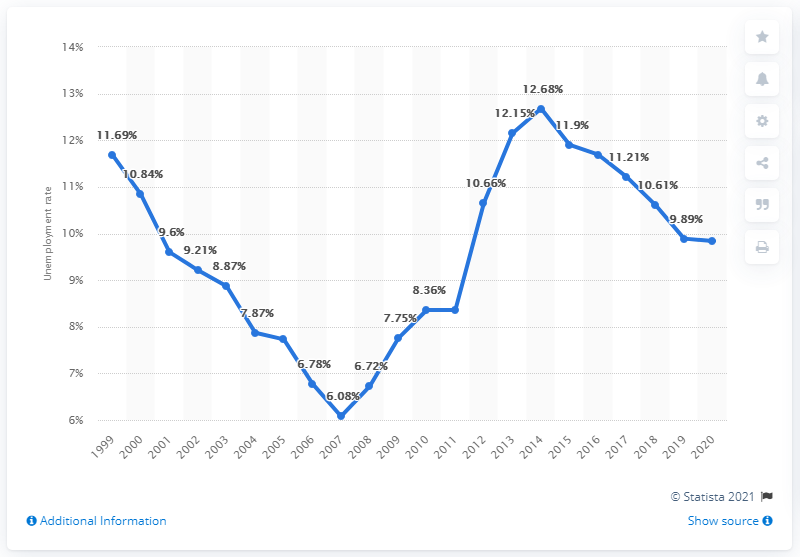Point out several critical features in this image. The unemployment rate in Italy in 2020 was 9.84%. 